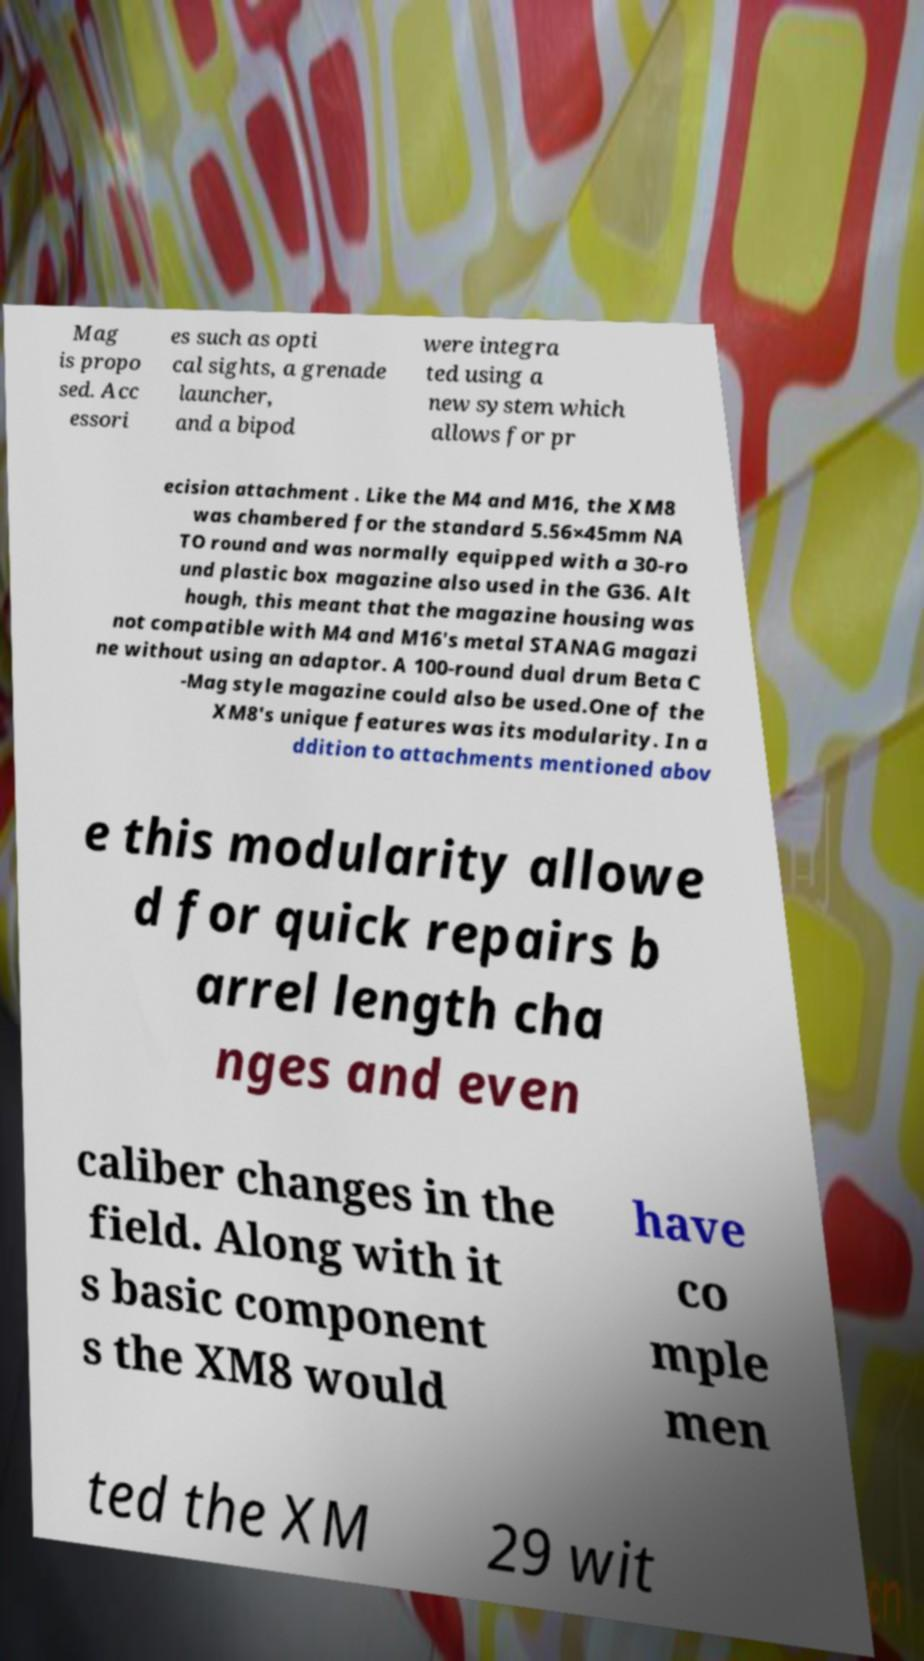For documentation purposes, I need the text within this image transcribed. Could you provide that? Mag is propo sed. Acc essori es such as opti cal sights, a grenade launcher, and a bipod were integra ted using a new system which allows for pr ecision attachment . Like the M4 and M16, the XM8 was chambered for the standard 5.56×45mm NA TO round and was normally equipped with a 30-ro und plastic box magazine also used in the G36. Alt hough, this meant that the magazine housing was not compatible with M4 and M16's metal STANAG magazi ne without using an adaptor. A 100-round dual drum Beta C -Mag style magazine could also be used.One of the XM8's unique features was its modularity. In a ddition to attachments mentioned abov e this modularity allowe d for quick repairs b arrel length cha nges and even caliber changes in the field. Along with it s basic component s the XM8 would have co mple men ted the XM 29 wit 